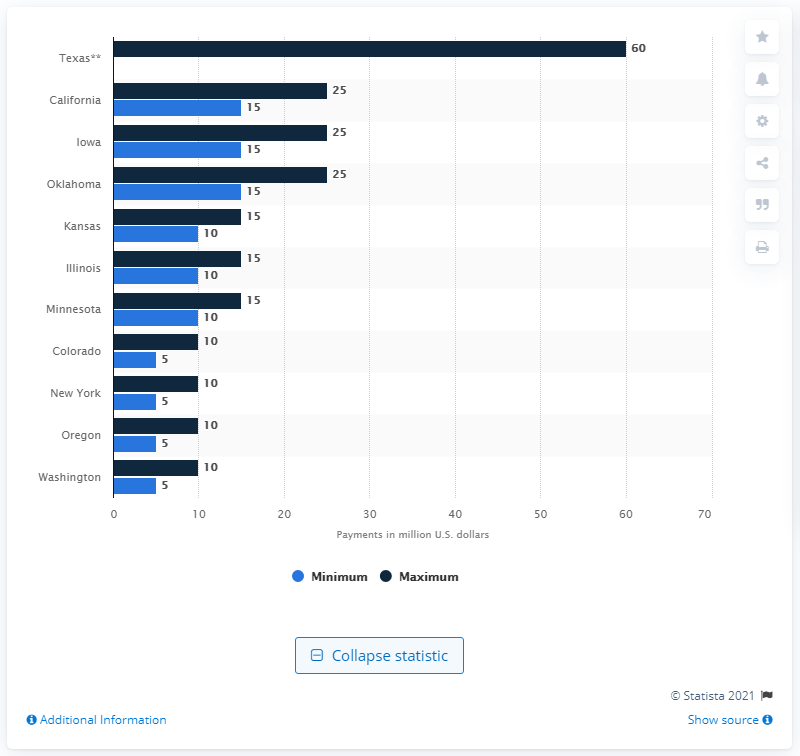Point out several critical features in this image. In 2016, the estimated annual lease payments for wind power projects in Texas were approximately $60 million. 